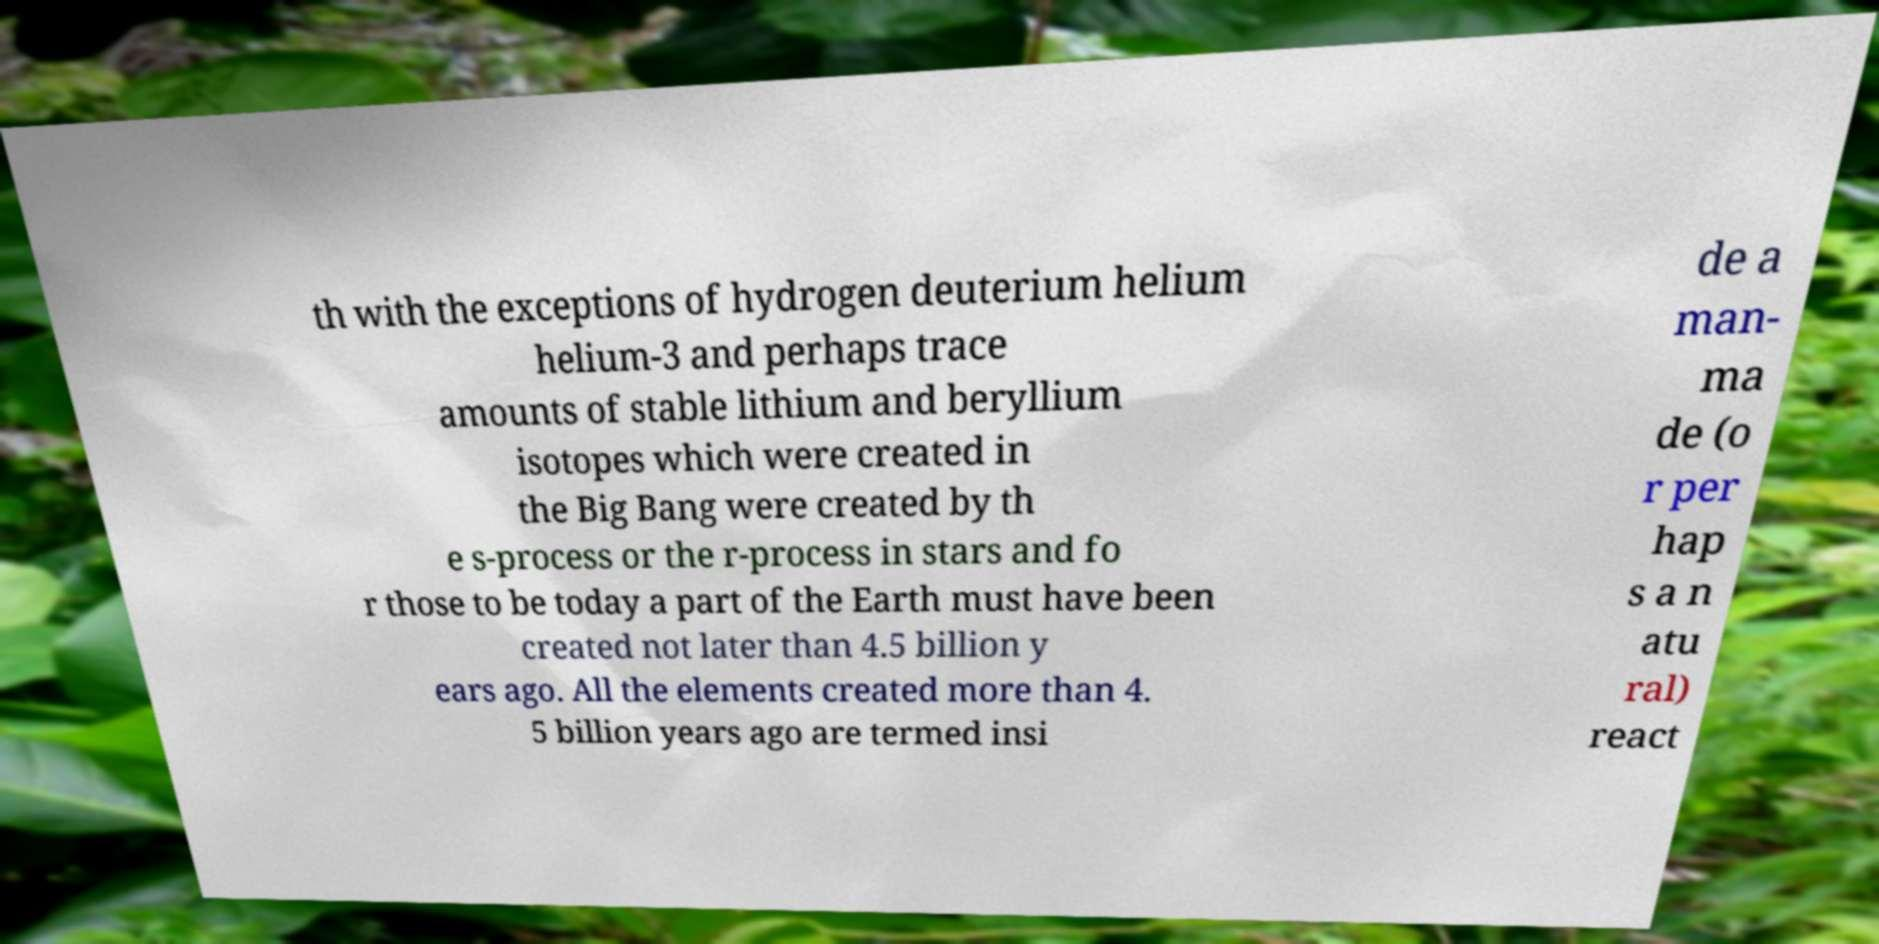I need the written content from this picture converted into text. Can you do that? th with the exceptions of hydrogen deuterium helium helium-3 and perhaps trace amounts of stable lithium and beryllium isotopes which were created in the Big Bang were created by th e s-process or the r-process in stars and fo r those to be today a part of the Earth must have been created not later than 4.5 billion y ears ago. All the elements created more than 4. 5 billion years ago are termed insi de a man- ma de (o r per hap s a n atu ral) react 